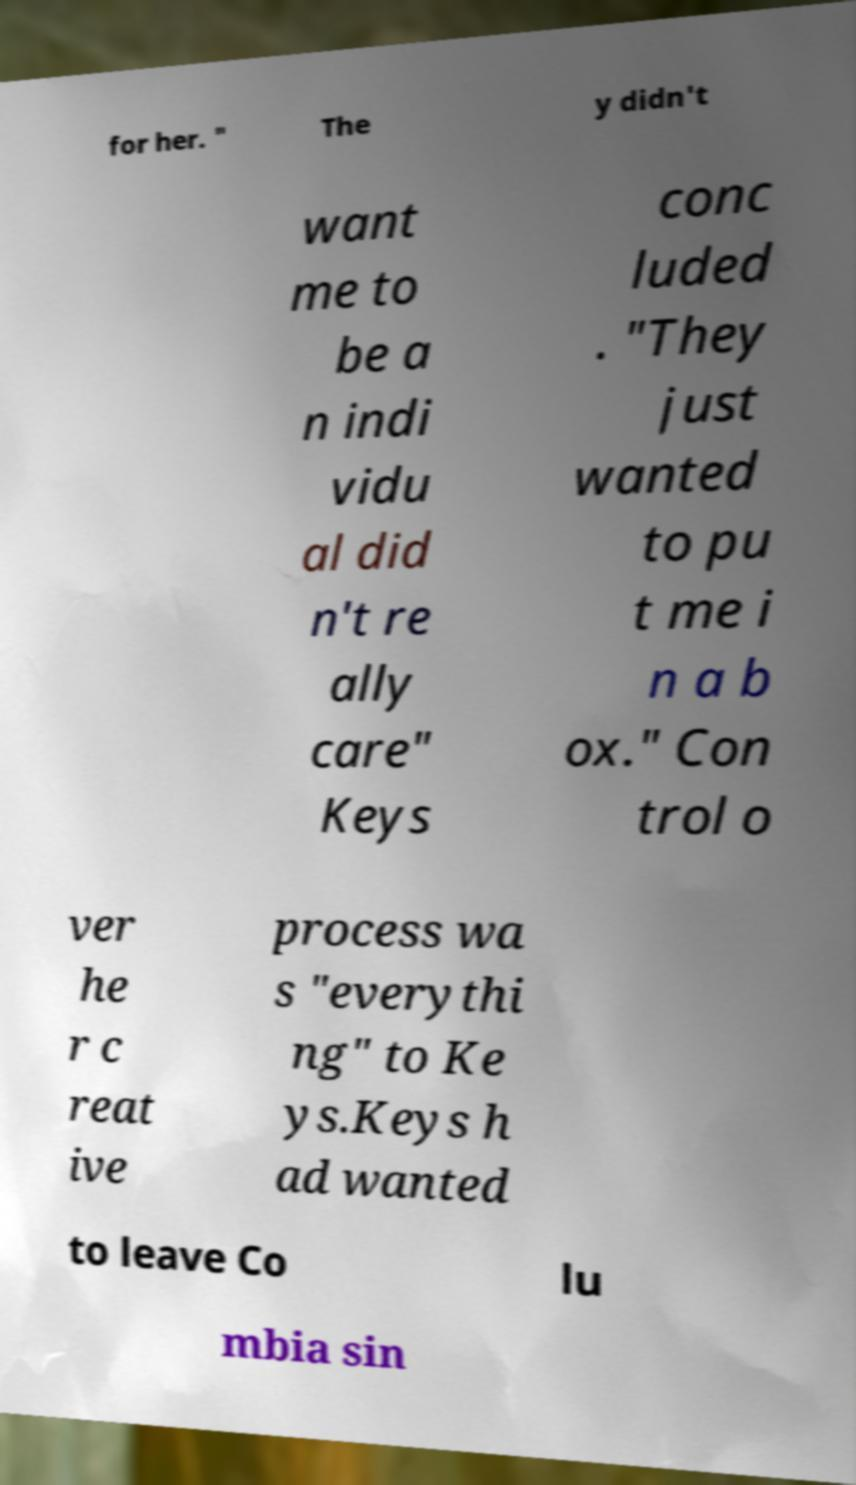Can you read and provide the text displayed in the image?This photo seems to have some interesting text. Can you extract and type it out for me? for her. " The y didn't want me to be a n indi vidu al did n't re ally care" Keys conc luded . "They just wanted to pu t me i n a b ox." Con trol o ver he r c reat ive process wa s "everythi ng" to Ke ys.Keys h ad wanted to leave Co lu mbia sin 